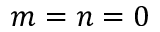Convert formula to latex. <formula><loc_0><loc_0><loc_500><loc_500>m = n = 0</formula> 